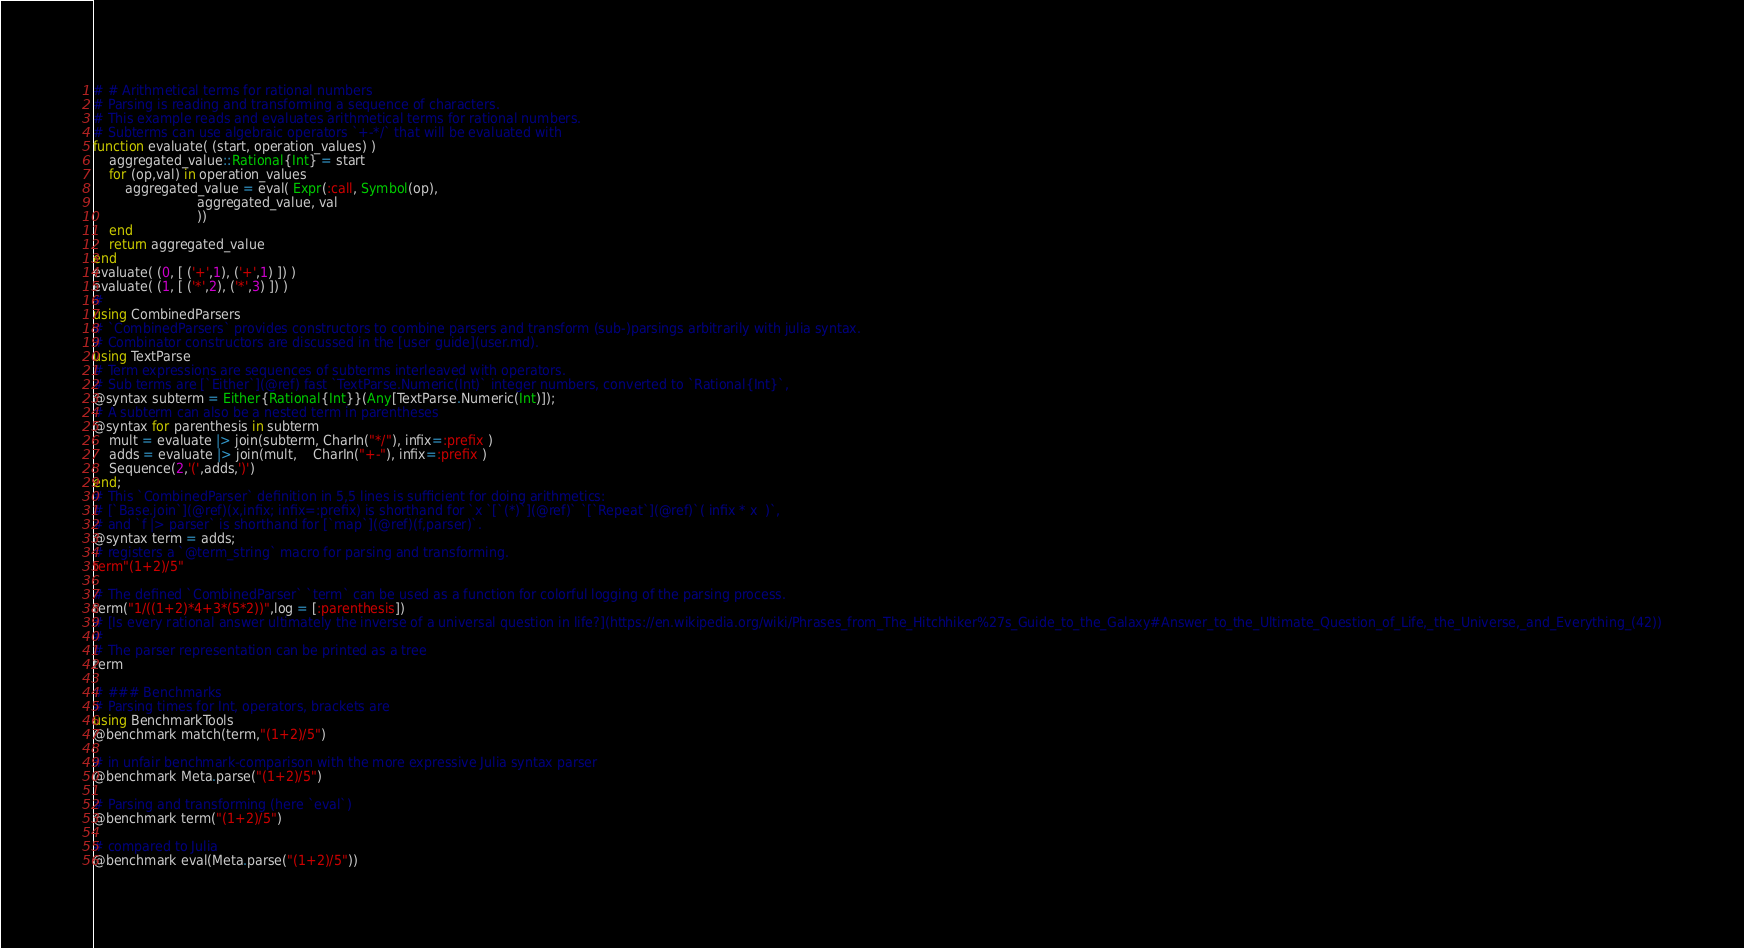<code> <loc_0><loc_0><loc_500><loc_500><_Julia_># # Arithmetical terms for rational numbers
# Parsing is reading and transforming a sequence of characters.
# This example reads and evaluates arithmetical terms for rational numbers.
# Subterms can use algebraic operators `+-*/` that will be evaluated with 
function evaluate( (start, operation_values) )
    aggregated_value::Rational{Int} = start
    for (op,val) in operation_values
        aggregated_value = eval( Expr(:call, Symbol(op), 
			              aggregated_value, val
			              ))
    end
    return aggregated_value
end
evaluate( (0, [ ('+',1), ('+',1) ]) )
evaluate( (1, [ ('*',2), ('*',3) ]) )
#
using CombinedParsers
# `CombinedParsers` provides constructors to combine parsers and transform (sub-)parsings arbitrarily with julia syntax.
# Combinator constructors are discussed in the [user guide](user.md).
using TextParse
# Term expressions are sequences of subterms interleaved with operators.
# Sub terms are [`Either`](@ref) fast `TextParse.Numeric(Int)` integer numbers, converted to `Rational{Int}`,
@syntax subterm = Either{Rational{Int}}(Any[TextParse.Numeric(Int)]);
# A subterm can also be a nested term in parentheses
@syntax for parenthesis in subterm
    mult = evaluate |> join(subterm, CharIn("*/"), infix=:prefix )
    adds = evaluate |> join(mult,    CharIn("+-"), infix=:prefix )
    Sequence(2,'(',adds,')')
end;
# This `CombinedParser` definition in 5,5 lines is sufficient for doing arithmetics:
# [`Base.join`](@ref)(x,infix; infix=:prefix) is shorthand for `x `[`(*)`](@ref)` `[`Repeat`](@ref)`( infix * x  )`,
# and `f |> parser` is shorthand for [`map`](@ref)(f,parser)`.
@syntax term = adds;
# registers a `@term_string` macro for parsing and transforming.
term"(1+2)/5"

# The defined `CombinedParser` `term` can be used as a function for colorful logging of the parsing process.
term("1/((1+2)*4+3*(5*2))",log = [:parenthesis])
# [Is every rational answer ultimately the inverse of a universal question in life?](https://en.wikipedia.org/wiki/Phrases_from_The_Hitchhiker%27s_Guide_to_the_Galaxy#Answer_to_the_Ultimate_Question_of_Life,_the_Universe,_and_Everything_(42))
#
# The parser representation can be printed as a tree
term

# ### Benchmarks
# Parsing times for Int, operators, brackets are
using BenchmarkTools
@benchmark match(term,"(1+2)/5") 

# in unfair benchmark-comparison with the more expressive Julia syntax parser
@benchmark Meta.parse("(1+2)/5")

# Parsing and transforming (here `eval`)
@benchmark term("(1+2)/5") 

# compared to Julia 
@benchmark eval(Meta.parse("(1+2)/5"))

</code> 